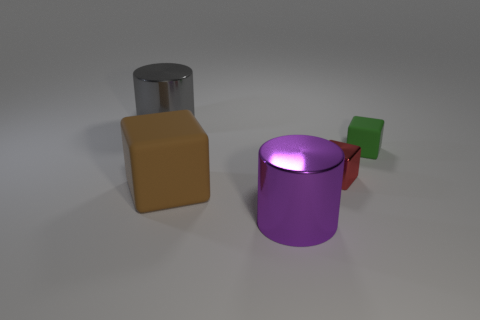Subtract all tiny blocks. How many blocks are left? 1 Subtract 2 blocks. How many blocks are left? 1 Add 5 large purple things. How many objects exist? 10 Subtract all red cubes. How many cubes are left? 2 Subtract all blocks. How many objects are left? 2 Subtract all green cylinders. How many brown cubes are left? 1 Subtract all big gray objects. Subtract all large gray objects. How many objects are left? 3 Add 5 purple metal cylinders. How many purple metal cylinders are left? 6 Add 1 small green blocks. How many small green blocks exist? 2 Subtract 0 blue cylinders. How many objects are left? 5 